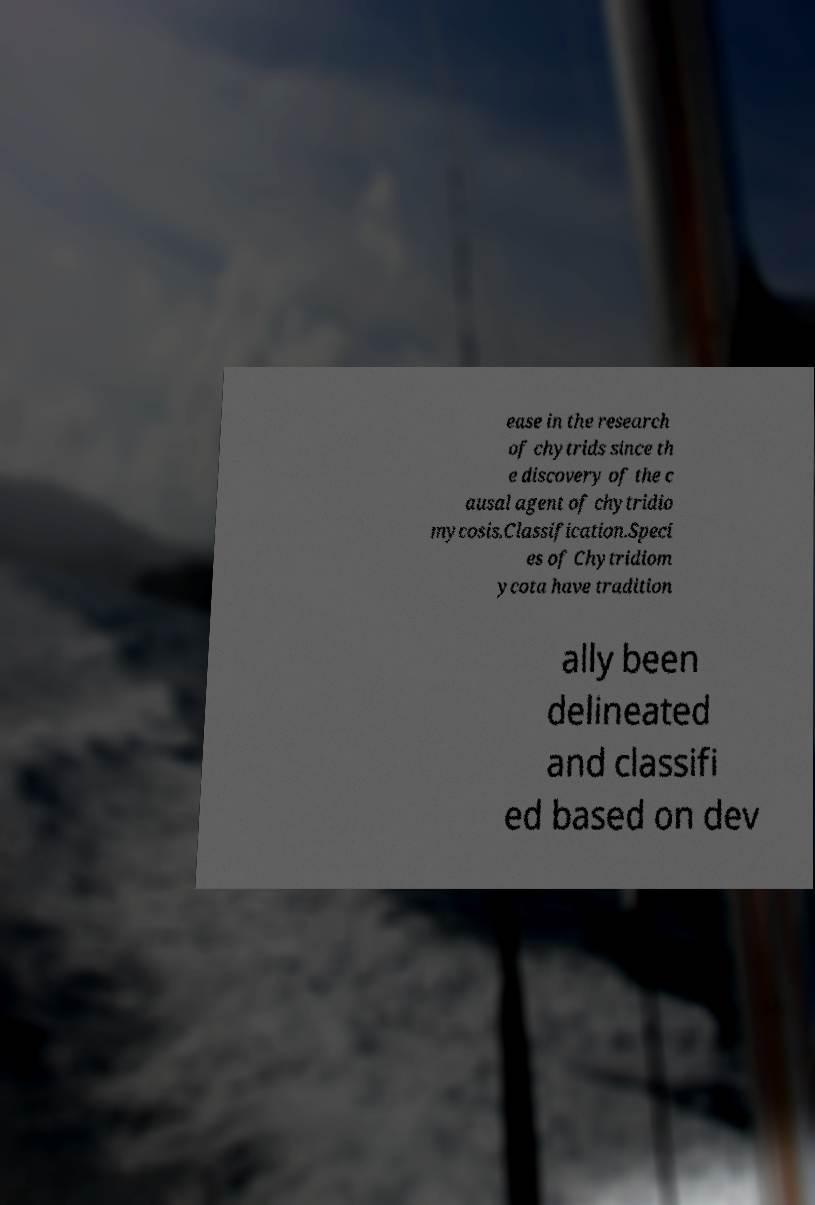Can you accurately transcribe the text from the provided image for me? ease in the research of chytrids since th e discovery of the c ausal agent of chytridio mycosis.Classification.Speci es of Chytridiom ycota have tradition ally been delineated and classifi ed based on dev 